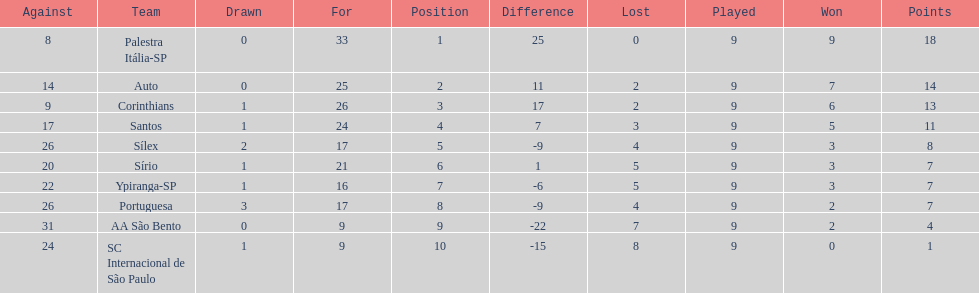How many points did the brazilian football team auto get in 1926? 14. 